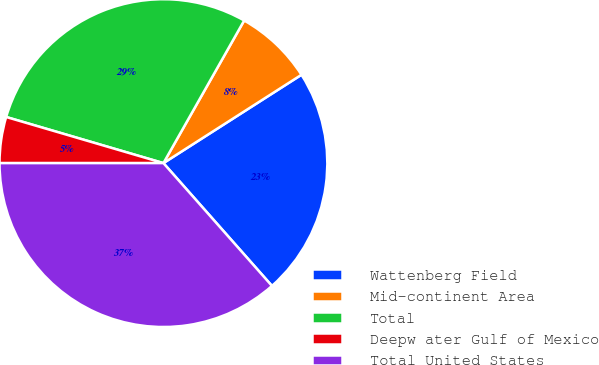<chart> <loc_0><loc_0><loc_500><loc_500><pie_chart><fcel>Wattenberg Field<fcel>Mid-continent Area<fcel>Total<fcel>Deepw ater Gulf of Mexico<fcel>Total United States<nl><fcel>22.54%<fcel>7.74%<fcel>28.66%<fcel>4.54%<fcel>36.52%<nl></chart> 